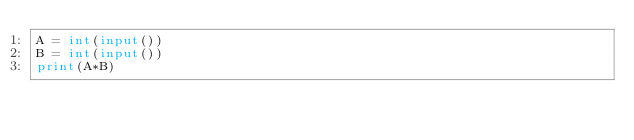<code> <loc_0><loc_0><loc_500><loc_500><_Python_>A = int(input())
B = int(input())
print(A*B)</code> 